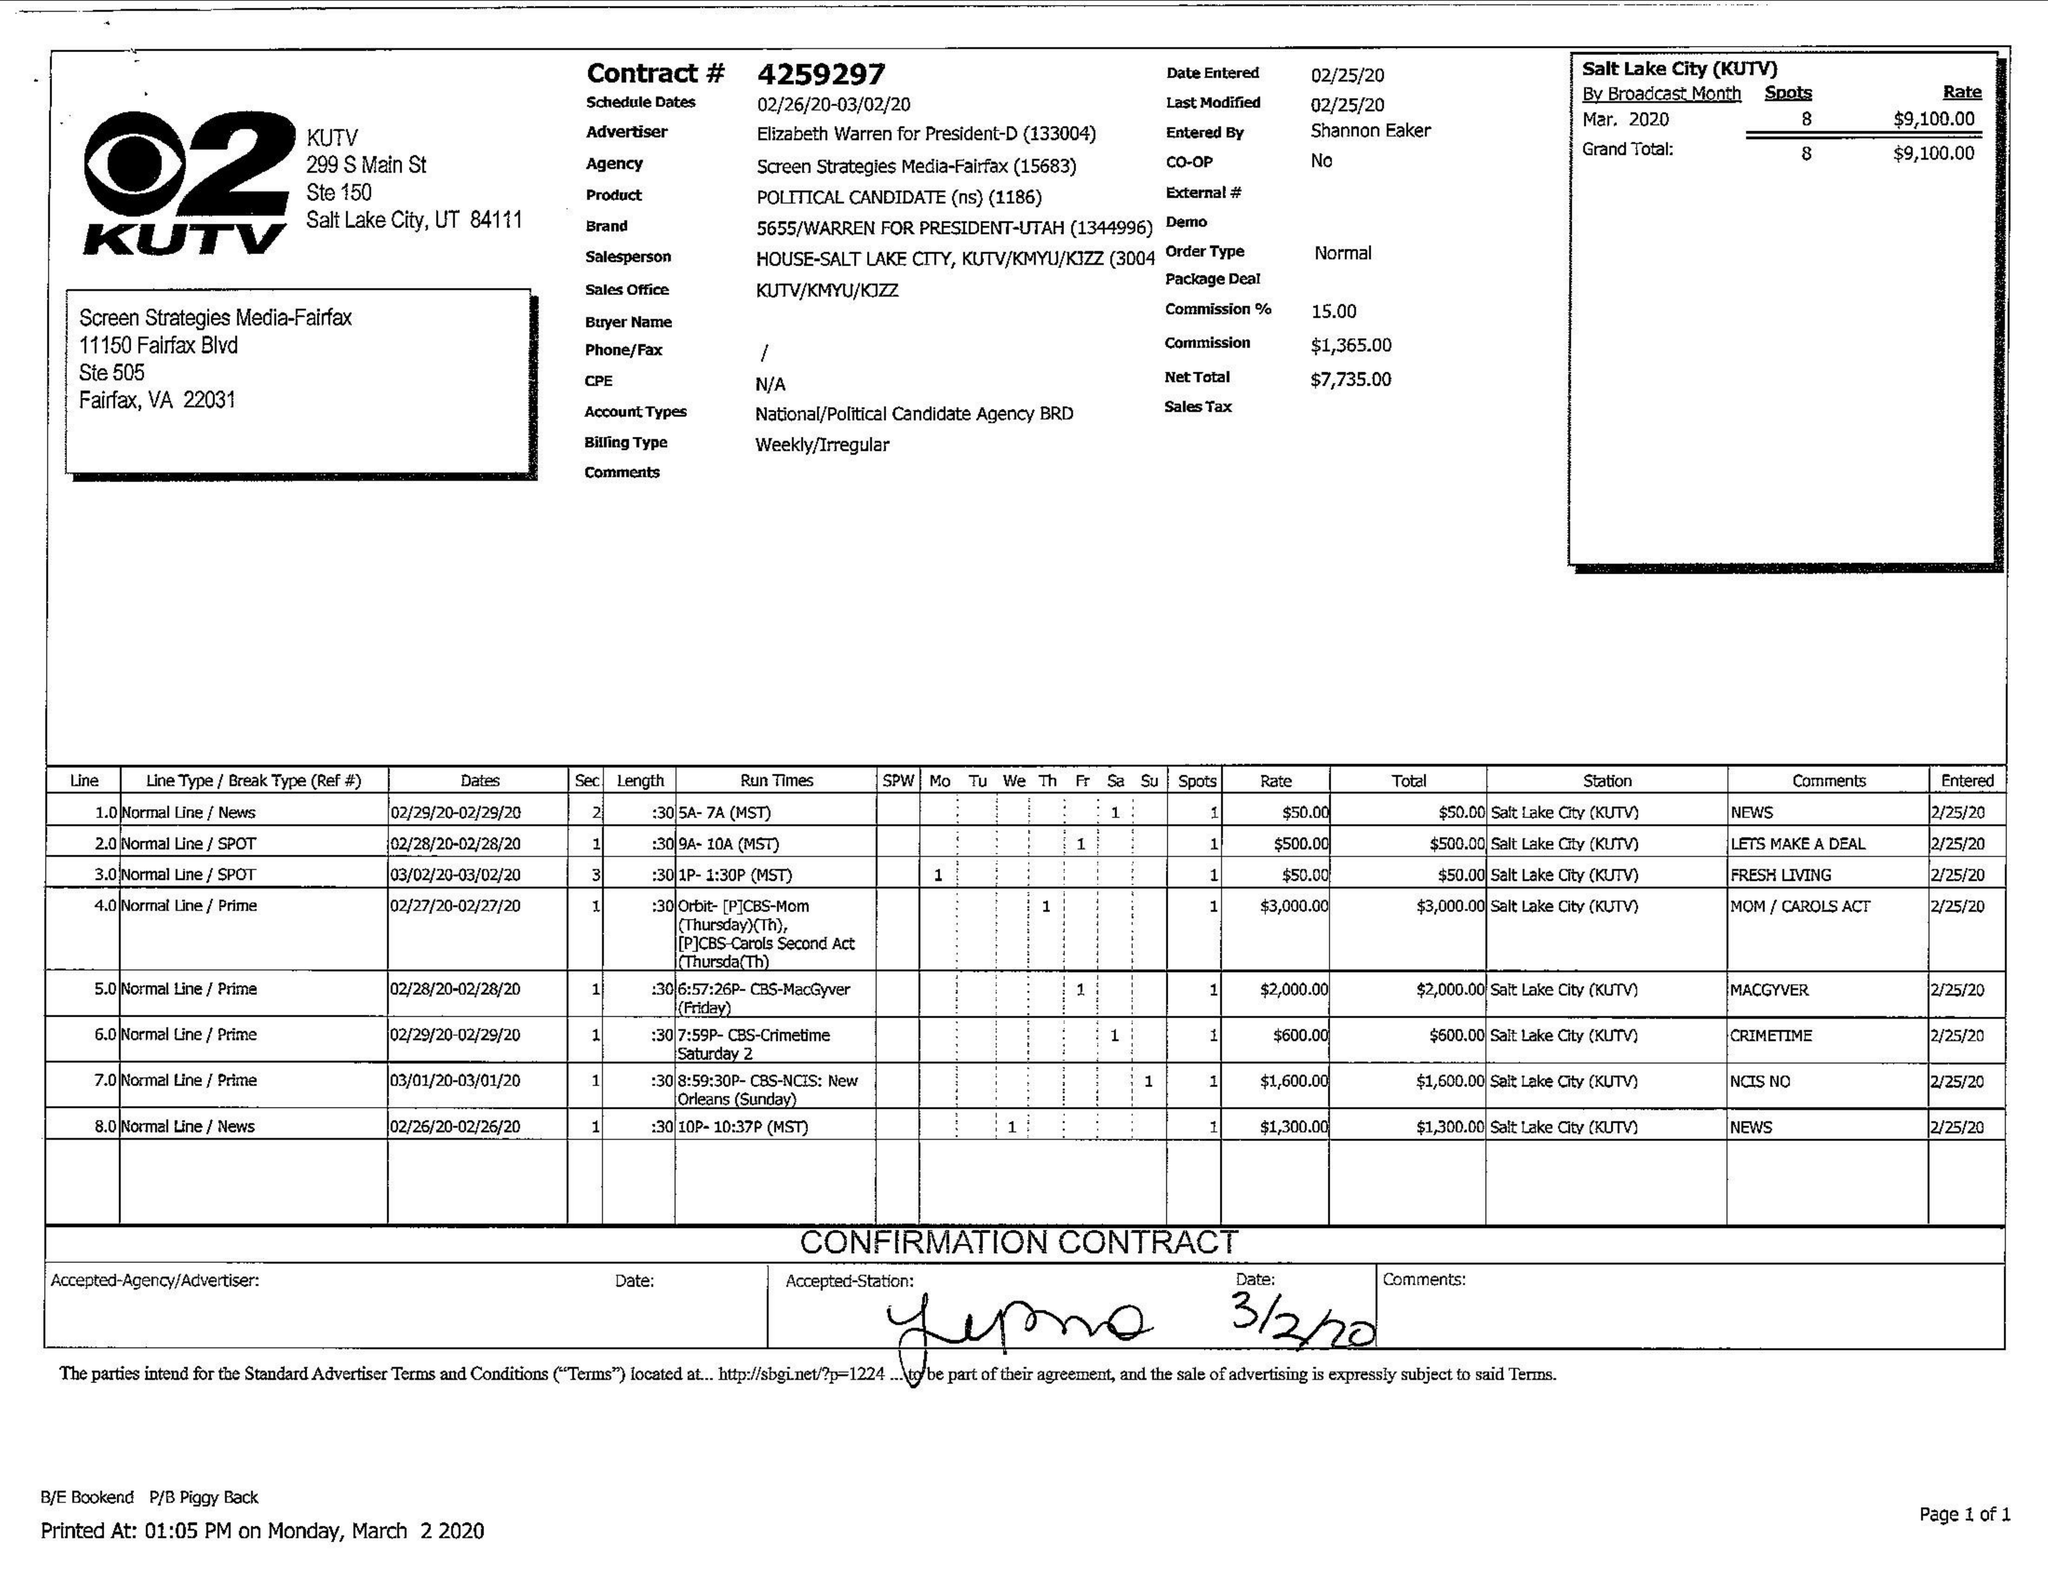What is the value for the contract_num?
Answer the question using a single word or phrase. 4259297 